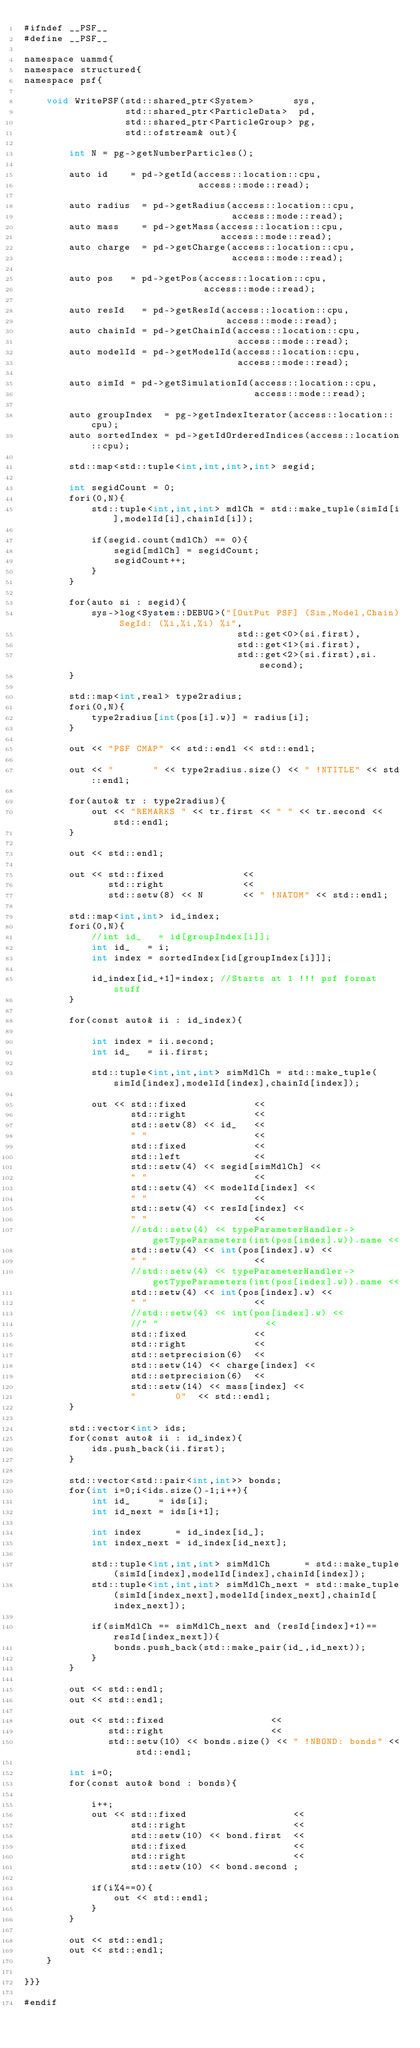Convert code to text. <code><loc_0><loc_0><loc_500><loc_500><_Cuda_>#ifndef __PSF__
#define __PSF__

namespace uammd{
namespace structured{
namespace psf{

    void WritePSF(std::shared_ptr<System>       sys,
                  std::shared_ptr<ParticleData>  pd,
                  std::shared_ptr<ParticleGroup> pg,
                  std::ofstream& out){

        int N = pg->getNumberParticles();
        
        auto id    = pd->getId(access::location::cpu, 
                               access::mode::read);
    
        auto radius  = pd->getRadius(access::location::cpu, 
                                     access::mode::read);
        auto mass    = pd->getMass(access::location::cpu, 
                                   access::mode::read);
        auto charge  = pd->getCharge(access::location::cpu, 
                                     access::mode::read);
                
        auto pos   = pd->getPos(access::location::cpu, 
                                access::mode::read);
        
        auto resId   = pd->getResId(access::location::cpu, 
                                    access::mode::read);
        auto chainId = pd->getChainId(access::location::cpu, 
                                      access::mode::read);
        auto modelId = pd->getModelId(access::location::cpu, 
                                      access::mode::read);
        
        auto simId = pd->getSimulationId(access::location::cpu, 
                                         access::mode::read);
    
        auto groupIndex  = pg->getIndexIterator(access::location::cpu);
        auto sortedIndex = pd->getIdOrderedIndices(access::location::cpu);
    
        std::map<std::tuple<int,int,int>,int> segid;
    
        int segidCount = 0;
        fori(0,N){
            std::tuple<int,int,int> mdlCh = std::make_tuple(simId[i],modelId[i],chainId[i]);
    
            if(segid.count(mdlCh) == 0){
                segid[mdlCh] = segidCount;
                segidCount++;
            }
        }
                
        for(auto si : segid){
            sys->log<System::DEBUG>("[OutPut PSF] (Sim,Model,Chain) SegId: (%i,%i,%i) %i",
                                      std::get<0>(si.first),
                                      std::get<1>(si.first),
                                      std::get<2>(si.first),si.second);
        }
    
        std::map<int,real> type2radius;
        fori(0,N){
            type2radius[int(pos[i].w)] = radius[i];
        }
    
        out << "PSF CMAP" << std::endl << std::endl;
        
        out << "       " << type2radius.size() << " !NTITLE" << std::endl; 

        for(auto& tr : type2radius){
            out << "REMARKS " << tr.first << " " << tr.second << std::endl;
        }

        out << std::endl;
    
        out << std::fixed              <<
               std::right              <<
               std::setw(8) << N       << " !NATOM" << std::endl; 
            
        std::map<int,int> id_index;
        fori(0,N){
            //int id_   = id[groupIndex[i]];
            int id_   = i;
            int index = sortedIndex[id[groupIndex[i]]];

            id_index[id_+1]=index; //Starts at 1 !!! psf format stuff
        }

        for(const auto& ii : id_index){

            int index = ii.second;
            int id_   = ii.first; 
            
            std::tuple<int,int,int> simMdlCh = std::make_tuple(simId[index],modelId[index],chainId[index]);
    
            out << std::fixed            <<
                   std::right            <<
                   std::setw(8) << id_   <<
                   " "                   <<
                   std::fixed            <<
                   std::left             <<
                   std::setw(4) << segid[simMdlCh] <<
                   " "                   <<
                   std::setw(4) << modelId[index] <<
                   " "                   <<
                   std::setw(4) << resId[index] <<
                   " "                   <<
                   //std::setw(4) << typeParameterHandler->getTypeParameters(int(pos[index].w)).name <<
                   std::setw(4) << int(pos[index].w) <<
                   " "                   <<
                   //std::setw(4) << typeParameterHandler->getTypeParameters(int(pos[index].w)).name <<
                   std::setw(4) << int(pos[index].w) <<
                   " "                   <<
                   //std::setw(4) << int(pos[index].w) <<
                   //" "                   <<
                   std::fixed            <<
                   std::right            <<
                   std::setprecision(6)  <<
                   std::setw(14) << charge[index] <<
                   std::setprecision(6)  <<
                   std::setw(14) << mass[index] <<
                   "       0"  << std::endl;
        }

        std::vector<int> ids;
        for(const auto& ii : id_index){
            ids.push_back(ii.first);
        }

        std::vector<std::pair<int,int>> bonds;
        for(int i=0;i<ids.size()-1;i++){
            int id_     = ids[i];
            int id_next = ids[i+1];

            int index      = id_index[id_];
            int index_next = id_index[id_next];

            std::tuple<int,int,int> simMdlCh      = std::make_tuple(simId[index],modelId[index],chainId[index]);
            std::tuple<int,int,int> simMdlCh_next = std::make_tuple(simId[index_next],modelId[index_next],chainId[index_next]);

            if(simMdlCh == simMdlCh_next and (resId[index]+1)==resId[index_next]){
                bonds.push_back(std::make_pair(id_,id_next));
            }
        }
                
        out << std::endl;
        out << std::endl;
        
        out << std::fixed                   <<
               std::right                   <<
               std::setw(10) << bonds.size() << " !NBOND: bonds" << std::endl; 

        int i=0;
        for(const auto& bond : bonds){

            i++;
            out << std::fixed                   <<
                   std::right                   <<
                   std::setw(10) << bond.first  <<
                   std::fixed                   <<
                   std::right                   <<
                   std::setw(10) << bond.second ;

            if(i%4==0){
                out << std::endl;
            }
        }
        
        out << std::endl;
        out << std::endl;
    }

}}}

#endif
</code> 